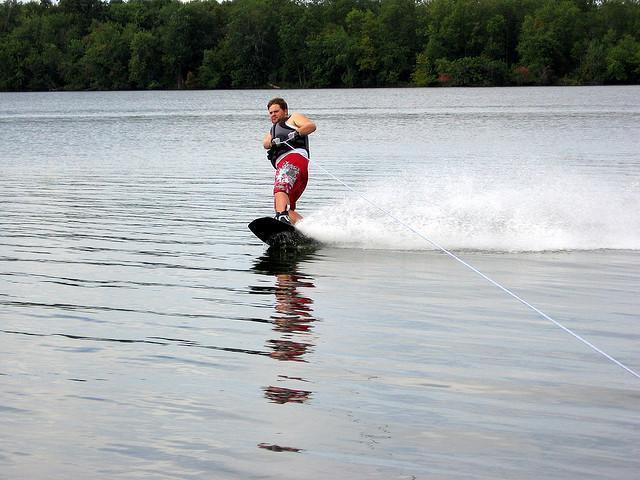How many red umbrellas are to the right of the woman in the middle?
Give a very brief answer. 0. 